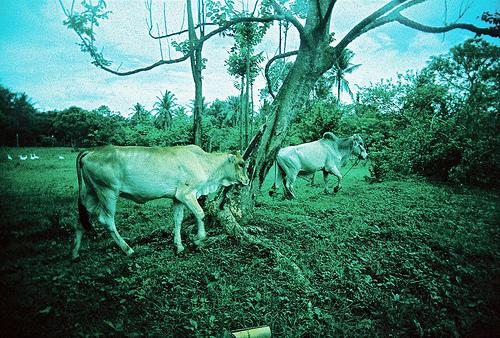What are two distinct trees present in the image, and where are they located? A large tree with twisting branches is in the center of the image, and a tall palm tree can be found on the side, closer to the edge. Write a haiku-inspired caption for this image. Nature intertwines. Explain the state of the grass in the image. The grass in the image is mostly short, green, and lush, with some areas covered by fallen leaves and vegetation. Can you count how many animals are present in the image? There are two bulls and several birds (ducks) in the image. In your opinion, what could be a possible reason or purpose for applying the filter in this image? The green filter may have been applied to enhance the natural colors of the image, making it more vibrant and emphasizing the lush vegetation. Identify any noticeable debris or waste in the image. There is trash on the ground, as well as a bottle lying amidst the vegetation. Describe the interaction between the two bulls in the image. The two bulls seem to be moving or walking together in the vicinity of the tree, possibly grazing or exploring their surroundings. Explain an object detection task related to this image. An object detection task for this image could involve identifying and labeling all key objects within the scene, such as bulls, ducks, trees, grass, and trash. How would you describe the overall mood or sentiment of the image? The image has a calm and serene mood, showing a peaceful interaction of animals in their natural habitat. What are the conditions of the tree's branches in the image? The tree's branches have few leaves, some of them are dead and hanging, giving the tree a tangled and twisted appearance. Name the birds present in the image. White ducks Describe the tree present in the image. Large tangled looking tree with twisting branches and barely any leaves Choose the correct description of the tree's roots from the following options: A) Root growing into the grass, B) Root hanging from the tree, C) Root submerged in water. A) Root growing into the grass What is the background of the image consist of? Trees grouped together, tall shrubs, and white ducks What type of branches can be seen on the tree? Dead branches hanging, branches on the side, and twisted branches What can be observed on the ground in the image? Leaves and vegetation, trash, and short grass How many birds can be seen in the image? White birds walking Is one cow thinner than the other? Yes Is there a rainbow in the sky after a recent rain shower? I heard it was a beautiful sight. There is no mention of a rainbow or rain in the given information. Instead, it is mentioned that the sky is partly cloudy. This instruction misleads the viewer into searching for a non-existent weather phenomenon in the image. I heard there was a mysterious hidden waterfall in the background behind the coconut trees. Can you spot it? I've always wanted to visit it. No, it's not mentioned in the image. The filter used on the photo is of which color? Green Is there any indication of the animals being restrained? Rope hanging off the animal's neck What is the state of the sky in the image? Clear and partly cloudy Describe the tail of the animal in the image. Long animal tail Is there any item on the ground that is not part of the natural environment? Bottle laying on the ground Is there a squirrel climbing up the tree trunk? I thought I saw some movement there. There is no mention of a squirrel or any other animal besides cows and birds in the image. This instruction misleads the viewer into searching for an animal that isn't present in the image. Are there any people in the distance having a picnic under the shade of the tall trees? I assumed this would be a popular spot for gatherings. There is no mention of people or picnic activities in the given information. This instruction misleads the viewer into searching for human presence that is not there in the image. Describe the grass in the image. Green color grass on the ground, short grass State the relationship between the cows and the objects around them. Cows walking by tree, one cow tied to the tree, cow walking over a dead branch What type of tree can be seen in the background? Palm tree and coconut trees Can you find any wildflowers blooming in the grass or at the base of the trees? I love how colorful they make the scene. There is no mention of any wildflowers or blooming plants in the given information. This instruction is misleading as it prompts the viewer to look for colorful plant life that doesn't exist in the image. How many cows are there in the image? Two Which animals are shown walking in the image? Two cows Are the cows stationary or moving in the image? Moving; walking 